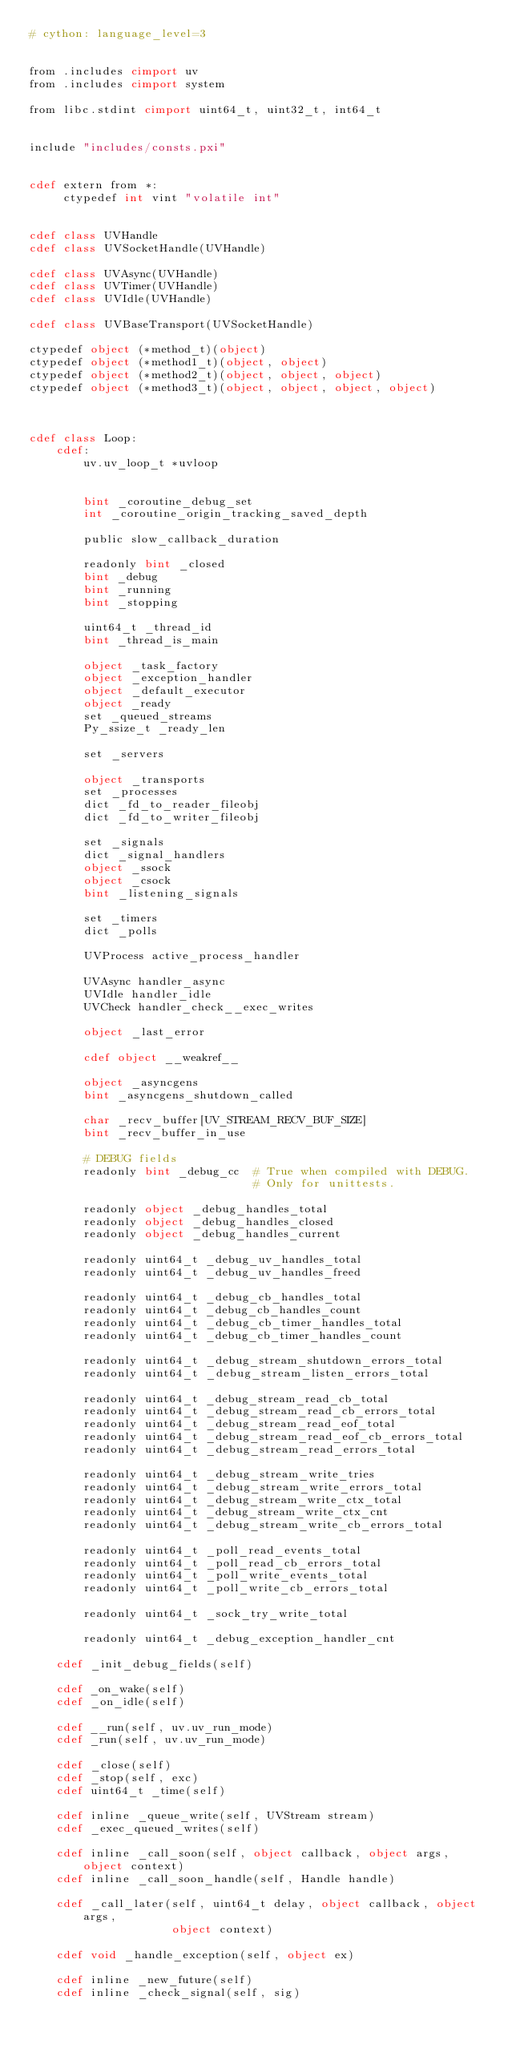Convert code to text. <code><loc_0><loc_0><loc_500><loc_500><_Cython_># cython: language_level=3


from .includes cimport uv
from .includes cimport system

from libc.stdint cimport uint64_t, uint32_t, int64_t


include "includes/consts.pxi"


cdef extern from *:
     ctypedef int vint "volatile int"


cdef class UVHandle
cdef class UVSocketHandle(UVHandle)

cdef class UVAsync(UVHandle)
cdef class UVTimer(UVHandle)
cdef class UVIdle(UVHandle)

cdef class UVBaseTransport(UVSocketHandle)

ctypedef object (*method_t)(object)
ctypedef object (*method1_t)(object, object)
ctypedef object (*method2_t)(object, object, object)
ctypedef object (*method3_t)(object, object, object, object)



cdef class Loop:
    cdef:
        uv.uv_loop_t *uvloop


        bint _coroutine_debug_set
        int _coroutine_origin_tracking_saved_depth

        public slow_callback_duration

        readonly bint _closed
        bint _debug
        bint _running
        bint _stopping

        uint64_t _thread_id
        bint _thread_is_main

        object _task_factory
        object _exception_handler
        object _default_executor
        object _ready
        set _queued_streams
        Py_ssize_t _ready_len

        set _servers

        object _transports
        set _processes
        dict _fd_to_reader_fileobj
        dict _fd_to_writer_fileobj

        set _signals
        dict _signal_handlers
        object _ssock
        object _csock
        bint _listening_signals

        set _timers
        dict _polls

        UVProcess active_process_handler

        UVAsync handler_async
        UVIdle handler_idle
        UVCheck handler_check__exec_writes

        object _last_error

        cdef object __weakref__

        object _asyncgens
        bint _asyncgens_shutdown_called

        char _recv_buffer[UV_STREAM_RECV_BUF_SIZE]
        bint _recv_buffer_in_use

        # DEBUG fields
        readonly bint _debug_cc  # True when compiled with DEBUG.
                                 # Only for unittests.

        readonly object _debug_handles_total
        readonly object _debug_handles_closed
        readonly object _debug_handles_current

        readonly uint64_t _debug_uv_handles_total
        readonly uint64_t _debug_uv_handles_freed

        readonly uint64_t _debug_cb_handles_total
        readonly uint64_t _debug_cb_handles_count
        readonly uint64_t _debug_cb_timer_handles_total
        readonly uint64_t _debug_cb_timer_handles_count

        readonly uint64_t _debug_stream_shutdown_errors_total
        readonly uint64_t _debug_stream_listen_errors_total

        readonly uint64_t _debug_stream_read_cb_total
        readonly uint64_t _debug_stream_read_cb_errors_total
        readonly uint64_t _debug_stream_read_eof_total
        readonly uint64_t _debug_stream_read_eof_cb_errors_total
        readonly uint64_t _debug_stream_read_errors_total

        readonly uint64_t _debug_stream_write_tries
        readonly uint64_t _debug_stream_write_errors_total
        readonly uint64_t _debug_stream_write_ctx_total
        readonly uint64_t _debug_stream_write_ctx_cnt
        readonly uint64_t _debug_stream_write_cb_errors_total

        readonly uint64_t _poll_read_events_total
        readonly uint64_t _poll_read_cb_errors_total
        readonly uint64_t _poll_write_events_total
        readonly uint64_t _poll_write_cb_errors_total

        readonly uint64_t _sock_try_write_total

        readonly uint64_t _debug_exception_handler_cnt

    cdef _init_debug_fields(self)

    cdef _on_wake(self)
    cdef _on_idle(self)

    cdef __run(self, uv.uv_run_mode)
    cdef _run(self, uv.uv_run_mode)

    cdef _close(self)
    cdef _stop(self, exc)
    cdef uint64_t _time(self)

    cdef inline _queue_write(self, UVStream stream)
    cdef _exec_queued_writes(self)

    cdef inline _call_soon(self, object callback, object args, object context)
    cdef inline _call_soon_handle(self, Handle handle)

    cdef _call_later(self, uint64_t delay, object callback, object args,
                     object context)

    cdef void _handle_exception(self, object ex)

    cdef inline _new_future(self)
    cdef inline _check_signal(self, sig)</code> 